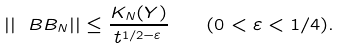Convert formula to latex. <formula><loc_0><loc_0><loc_500><loc_500>| | \ B { B } _ { N } | | \leq \frac { K _ { N } ( Y ) } { t ^ { 1 / 2 - \varepsilon } } \quad ( 0 < \varepsilon < 1 / 4 ) .</formula> 